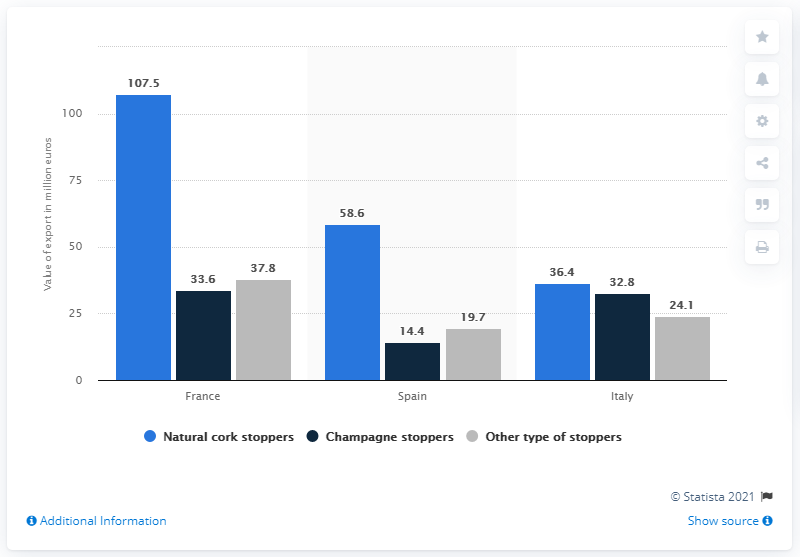Highlight a few significant elements in this photo. In 2018, the export value of cork stoppers from Portugal to France was €107.5 million. According to data from 2018, France was the leading export market for cork stoppers from Portugal. The total wine market in Italy is 93.3 million euros. France has the highest wine market in the world. 